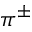Convert formula to latex. <formula><loc_0><loc_0><loc_500><loc_500>\pi ^ { \pm }</formula> 